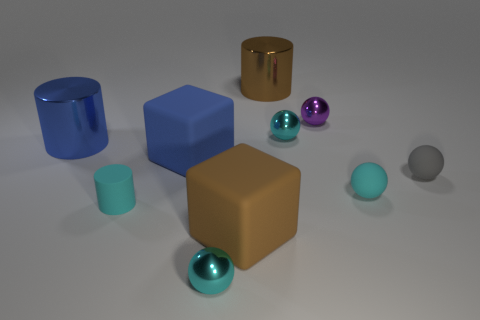There is a brown thing that is the same size as the brown cube; what is its material?
Offer a very short reply. Metal. Are there any blue cylinders that have the same size as the blue matte cube?
Provide a short and direct response. Yes. Is the number of cyan balls in front of the brown rubber cube the same as the number of big rubber cubes on the right side of the blue block?
Your answer should be very brief. Yes. Is the number of yellow metal cylinders greater than the number of brown matte cubes?
Your answer should be very brief. No. What number of matte objects are large blue cylinders or small purple balls?
Provide a short and direct response. 0. What number of balls have the same color as the rubber cylinder?
Your answer should be very brief. 3. What is the material of the large cylinder that is on the right side of the cyan metallic thing in front of the matte cube to the right of the large blue block?
Your response must be concise. Metal. There is a tiny metal sphere left of the large brown object in front of the gray object; what color is it?
Give a very brief answer. Cyan. How many tiny things are either matte balls or gray shiny objects?
Keep it short and to the point. 2. What number of other big blue cylinders have the same material as the large blue cylinder?
Offer a very short reply. 0. 